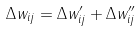Convert formula to latex. <formula><loc_0><loc_0><loc_500><loc_500>\Delta w _ { i j } = \Delta w _ { i j } ^ { \prime } + \Delta w _ { i j } ^ { \prime \prime }</formula> 